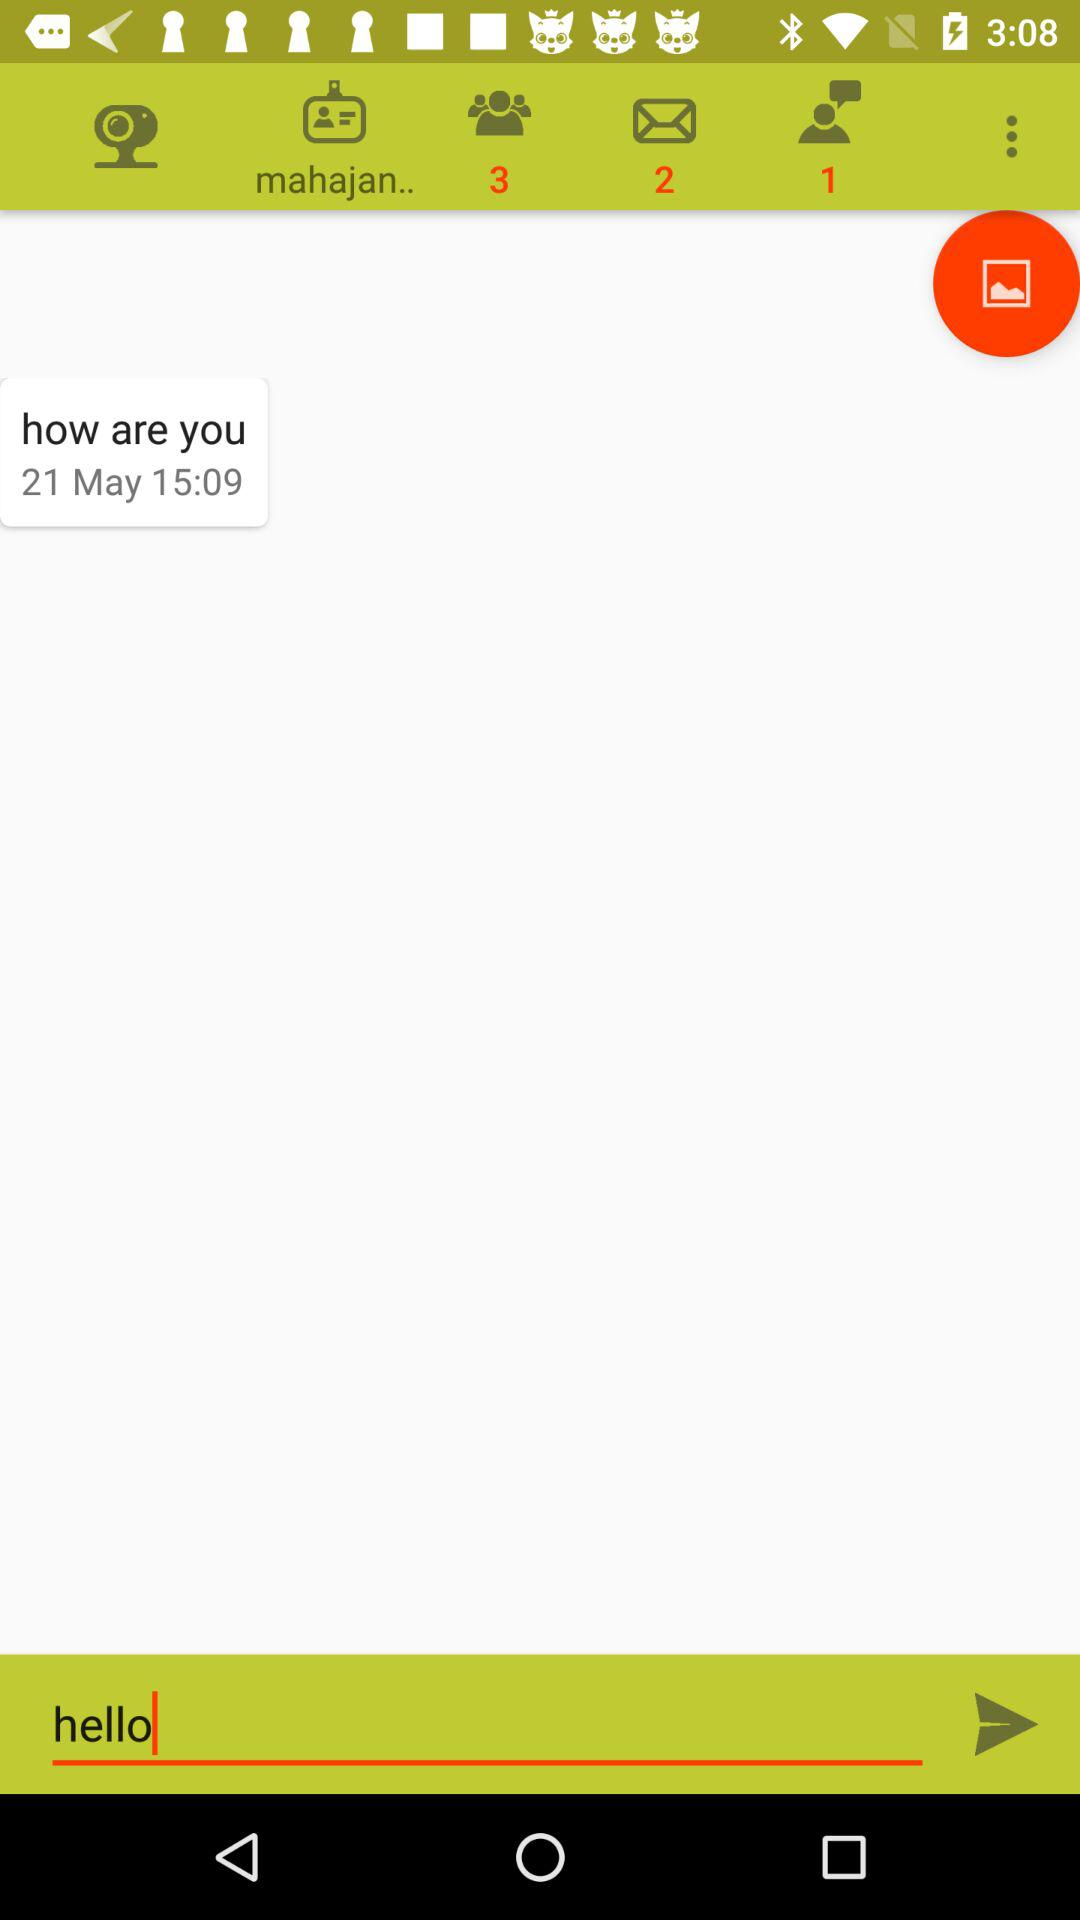On what date was the message received? The message was received on May 21. 